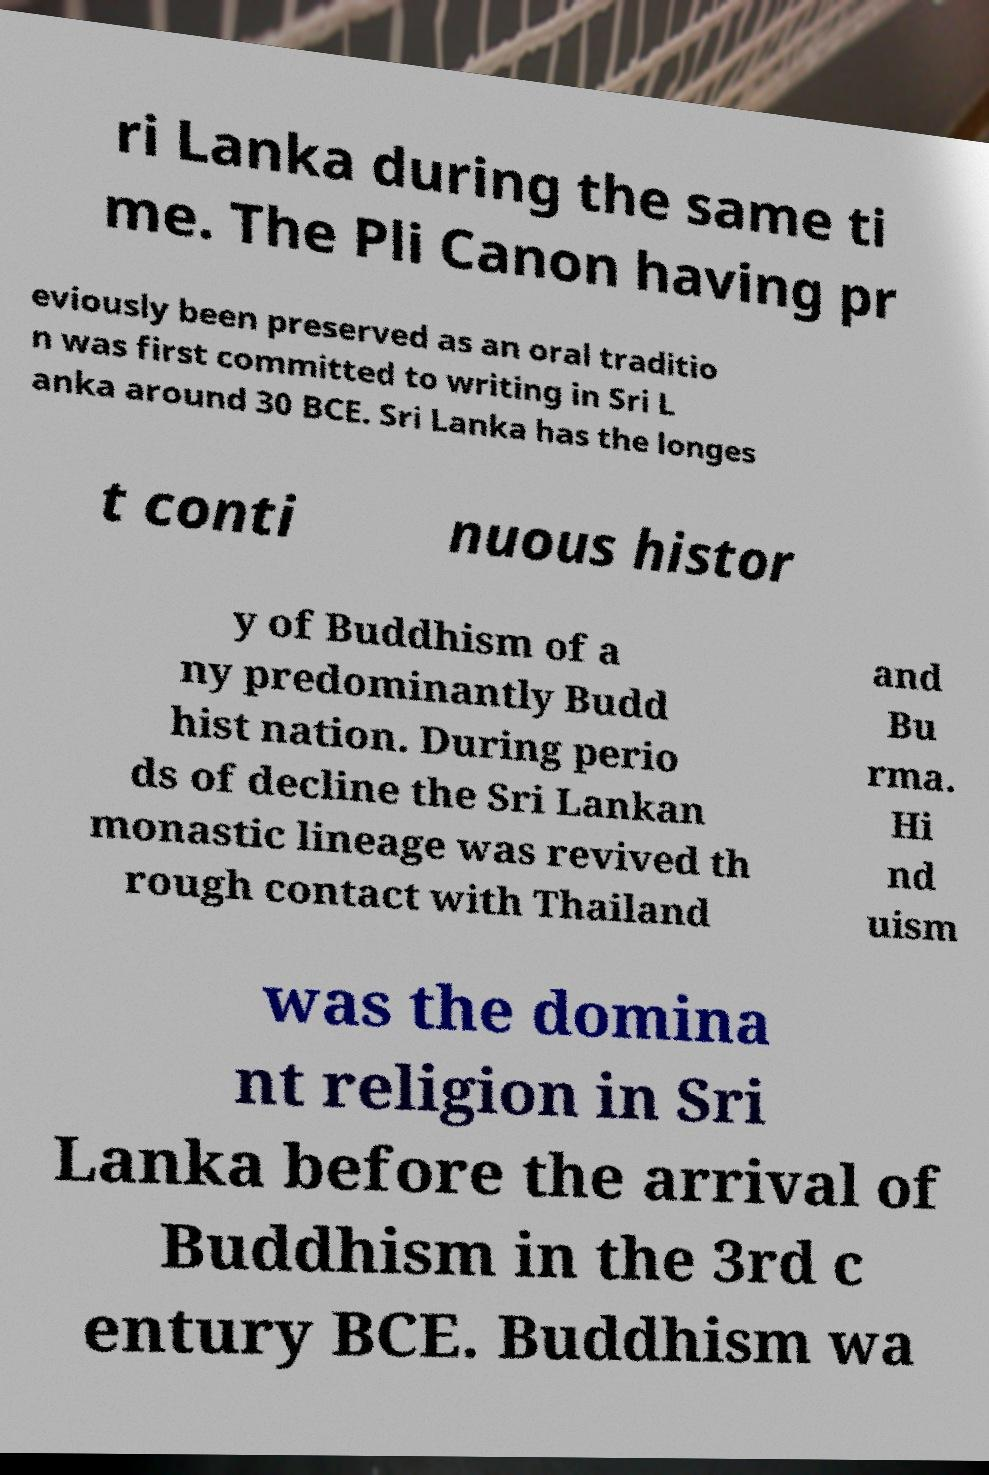Please identify and transcribe the text found in this image. ri Lanka during the same ti me. The Pli Canon having pr eviously been preserved as an oral traditio n was first committed to writing in Sri L anka around 30 BCE. Sri Lanka has the longes t conti nuous histor y of Buddhism of a ny predominantly Budd hist nation. During perio ds of decline the Sri Lankan monastic lineage was revived th rough contact with Thailand and Bu rma. Hi nd uism was the domina nt religion in Sri Lanka before the arrival of Buddhism in the 3rd c entury BCE. Buddhism wa 